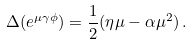<formula> <loc_0><loc_0><loc_500><loc_500>\Delta ( e ^ { \mu \gamma \phi } ) = \frac { 1 } { 2 } ( \eta \mu - \alpha \mu ^ { 2 } ) \, .</formula> 